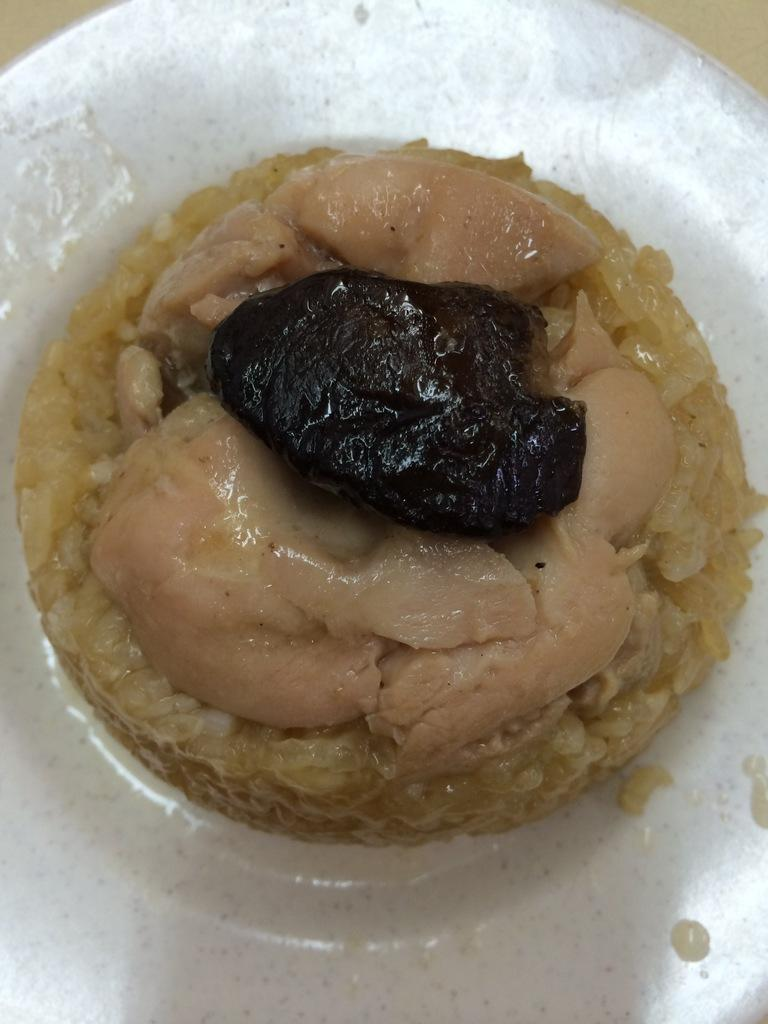What is on the plate that is visible in the image? There is a plate containing food in the image. Where is the plate located in the image? The plate is placed on a table in the image. How does the crow interact with the food on the plate in the image? There is no crow present in the image, so it cannot interact with the food on the plate. 